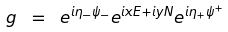Convert formula to latex. <formula><loc_0><loc_0><loc_500><loc_500>g \ = \ e ^ { i \eta _ { - } \psi _ { - } } e ^ { i x E + i y N } e ^ { i \eta _ { + } \psi ^ { + } } \,</formula> 